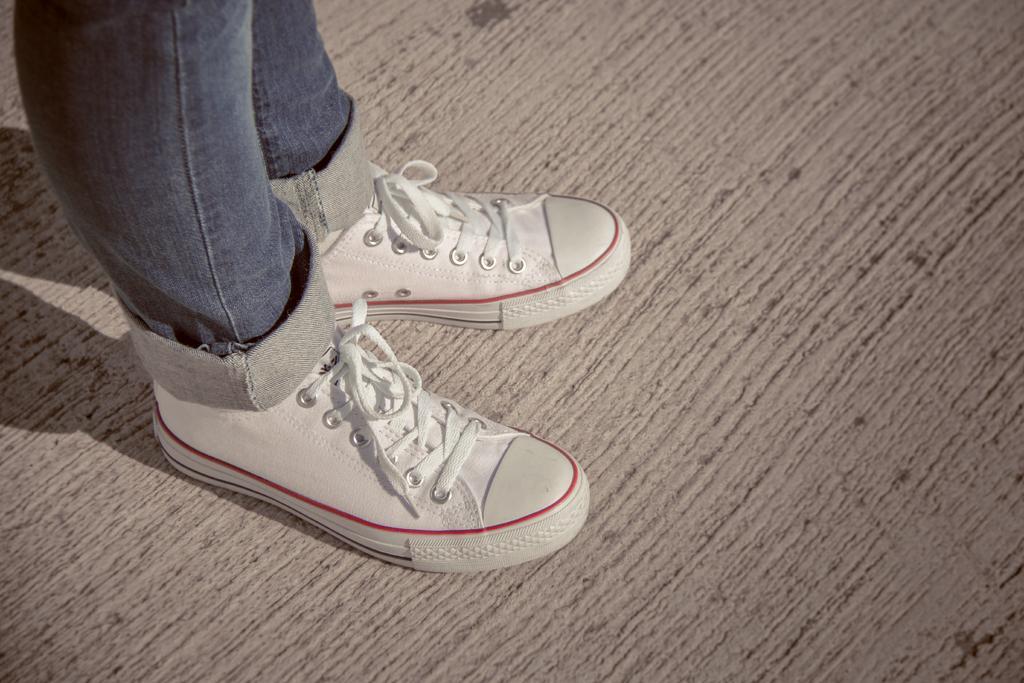Could you give a brief overview of what you see in this image? In this image I can see the person's legs. I can see the person is wearing the blue dress and shoes. I can see the person standing on the brown color surface. 